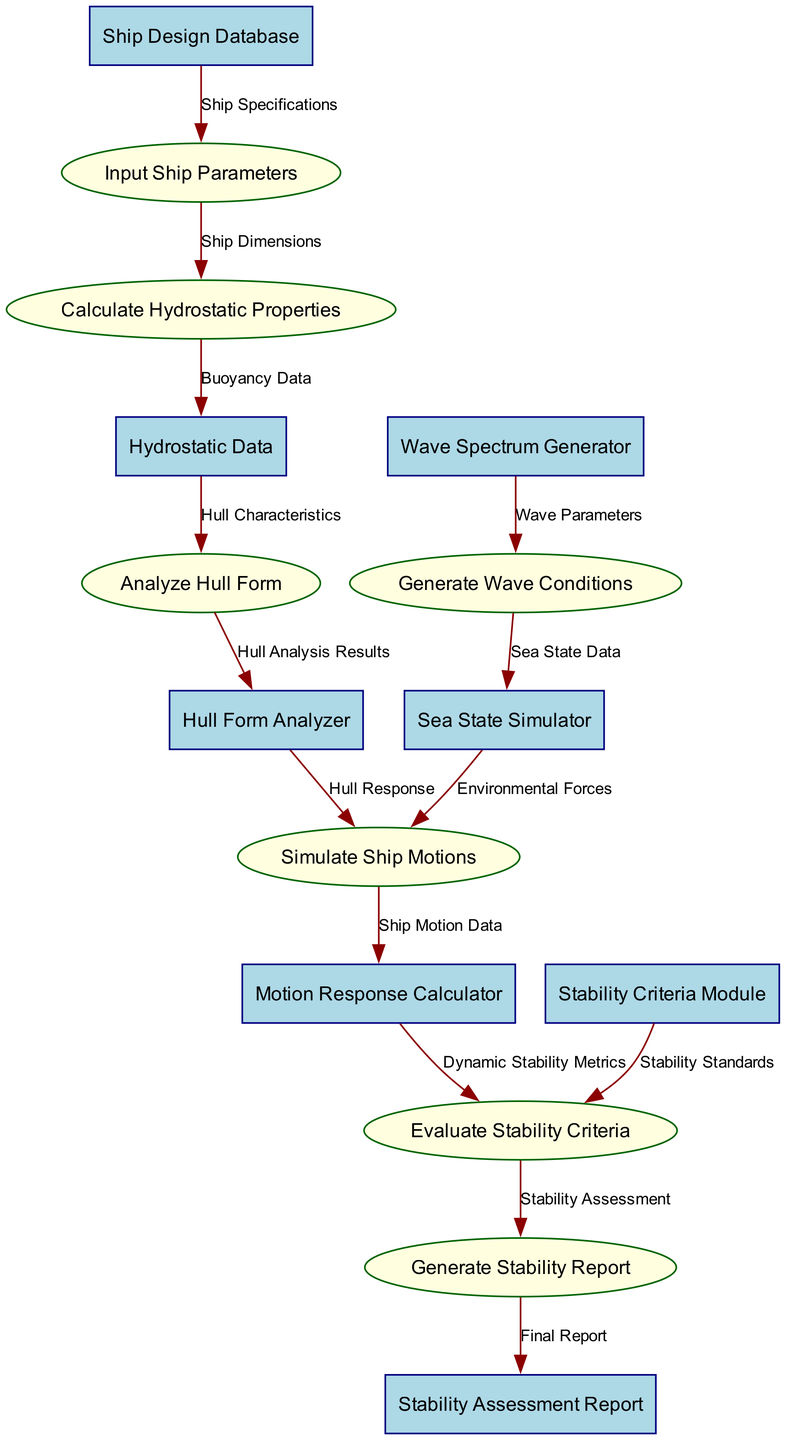What is the total number of nodes in the diagram? The diagram contains both entities and processes as nodes. There are 8 entities and 7 processes, giving a total of 15 nodes.
Answer: 15 What data flow connects the "Ship Design Database" and "Input Ship Parameters"? The data flow labeled "Ship Specifications" directly connects the "Ship Design Database" to "Input Ship Parameters".
Answer: Ship Specifications Which module evaluates stability criteria? The "Stability Criteria Module" is the designated module that evaluates stability criteria in the workflow.
Answer: Stability Criteria Module How many processes involve the "Simulate Ship Motions"? The "Simulate Ship Motions" process is involved in two data flows: one coming from "Sea State Simulator" and another from "Hull Form Analyzer". So, it is part of two data flows.
Answer: 2 What is the final output of the stability analysis workflow? The final output of the workflow is the "Stability Assessment Report" generated from the process "Generate Stability Report".
Answer: Stability Assessment Report Which entity provides the "Hull Characteristics"? The entity providing "Hull Characteristics" to the "Analyze Hull Form" process is the "Hydrostatic Data".
Answer: Hydrostatic Data What label describes the connection from "Generate Wave Conditions" to "Sea State Simulator"? The connection is labeled "Sea State Data" which specifies the type of data being transferred.
Answer: Sea State Data What are the two main sources of data used in the "Evaluate Stability Criteria"? The two primary sources of data for "Evaluate Stability Criteria" are "Dynamic Stability Metrics" from "Motion Response Calculator" and "Stability Standards" from "Stability Criteria Module".
Answer: Dynamic Stability Metrics and Stability Standards 